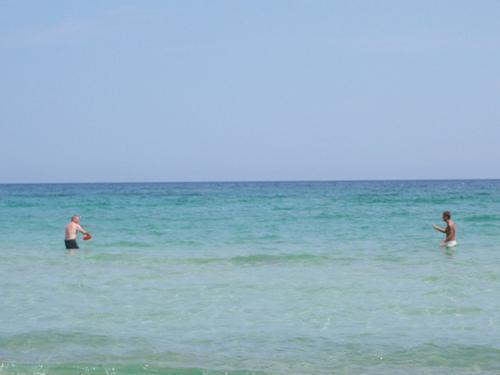Why does the man in white have his arm out?
Indicate the correct response by choosing from the four available options to answer the question.
Options: To wave, to catch, for balance, to reach. To catch. 